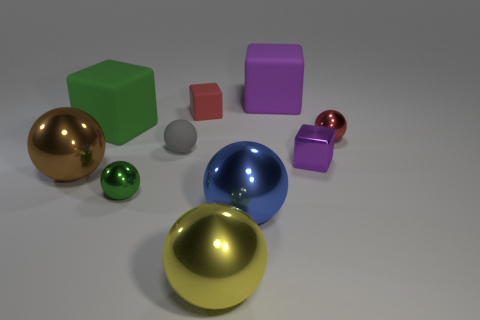Is there a blue metallic object that has the same size as the red matte thing?
Your response must be concise. No. There is a tiny block left of the small purple cube; is its color the same as the tiny metallic cube?
Provide a short and direct response. No. How many blue things are either small matte objects or matte cubes?
Keep it short and to the point. 0. How many other large cubes have the same color as the metal block?
Your response must be concise. 1. Is the material of the large green thing the same as the small gray object?
Ensure brevity in your answer.  Yes. What number of things are in front of the purple thing that is in front of the green rubber thing?
Your response must be concise. 4. Is the blue thing the same size as the red metallic object?
Your answer should be very brief. No. What number of small objects are the same material as the green ball?
Offer a very short reply. 2. What is the size of the other purple thing that is the same shape as the purple metallic thing?
Provide a short and direct response. Large. Does the large matte thing that is left of the green metallic sphere have the same shape as the large purple thing?
Give a very brief answer. Yes. 